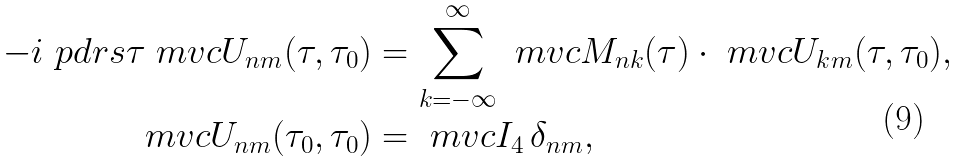<formula> <loc_0><loc_0><loc_500><loc_500>- i \ p d r s { \tau } \ m v c { U } _ { n m } ( \tau , \tau _ { 0 } ) & = \sum _ { k = - \infty } ^ { \infty } \ m v c { M } _ { n k } ( \tau ) \cdot \ m v c { U } _ { k m } ( \tau , \tau _ { 0 } ) , \\ \ m v c { U } _ { n m } ( \tau _ { 0 } , \tau _ { 0 } ) & = \ m v c { I } _ { 4 } \, \delta _ { n m } ,</formula> 